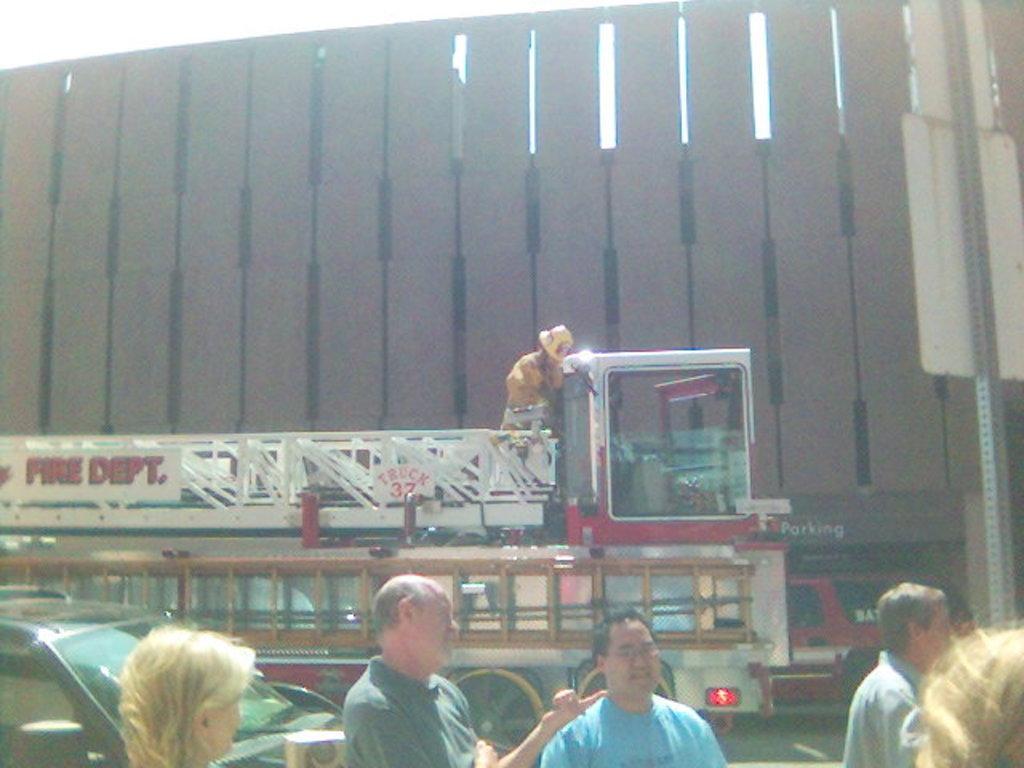Can you describe this image briefly? In this image there are group of people, car and goods vehicle on the road beside that there is a brown color building. 